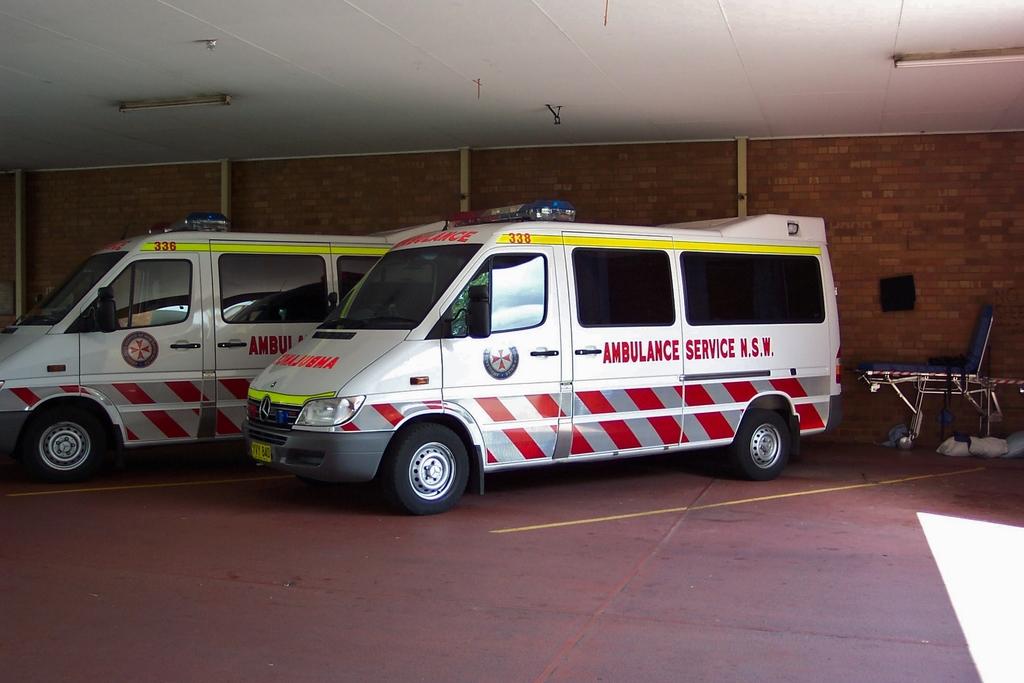What type of service vehicle is this?
Offer a terse response. Ambulance. What is wrote beside service on the vehicle?
Keep it short and to the point. Ambulance. 